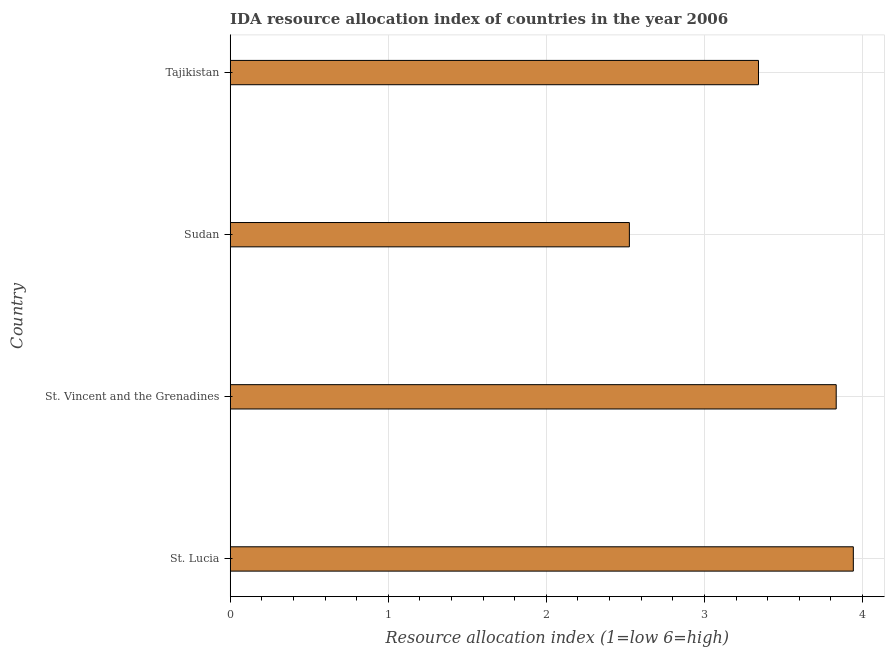Does the graph contain grids?
Offer a terse response. Yes. What is the title of the graph?
Your answer should be very brief. IDA resource allocation index of countries in the year 2006. What is the label or title of the X-axis?
Offer a very short reply. Resource allocation index (1=low 6=high). What is the ida resource allocation index in Tajikistan?
Make the answer very short. 3.34. Across all countries, what is the maximum ida resource allocation index?
Keep it short and to the point. 3.94. Across all countries, what is the minimum ida resource allocation index?
Offer a very short reply. 2.52. In which country was the ida resource allocation index maximum?
Make the answer very short. St. Lucia. In which country was the ida resource allocation index minimum?
Make the answer very short. Sudan. What is the sum of the ida resource allocation index?
Ensure brevity in your answer.  13.64. What is the difference between the ida resource allocation index in St. Lucia and Sudan?
Provide a succinct answer. 1.42. What is the average ida resource allocation index per country?
Keep it short and to the point. 3.41. What is the median ida resource allocation index?
Give a very brief answer. 3.59. In how many countries, is the ida resource allocation index greater than 2.6 ?
Your answer should be compact. 3. What is the ratio of the ida resource allocation index in St. Vincent and the Grenadines to that in Sudan?
Ensure brevity in your answer.  1.52. Is the difference between the ida resource allocation index in Sudan and Tajikistan greater than the difference between any two countries?
Your response must be concise. No. What is the difference between the highest and the second highest ida resource allocation index?
Offer a very short reply. 0.11. Is the sum of the ida resource allocation index in St. Lucia and Tajikistan greater than the maximum ida resource allocation index across all countries?
Your response must be concise. Yes. What is the difference between the highest and the lowest ida resource allocation index?
Offer a very short reply. 1.42. Are all the bars in the graph horizontal?
Offer a very short reply. Yes. How many countries are there in the graph?
Offer a terse response. 4. What is the Resource allocation index (1=low 6=high) in St. Lucia?
Give a very brief answer. 3.94. What is the Resource allocation index (1=low 6=high) in St. Vincent and the Grenadines?
Make the answer very short. 3.83. What is the Resource allocation index (1=low 6=high) in Sudan?
Keep it short and to the point. 2.52. What is the Resource allocation index (1=low 6=high) of Tajikistan?
Your response must be concise. 3.34. What is the difference between the Resource allocation index (1=low 6=high) in St. Lucia and St. Vincent and the Grenadines?
Provide a short and direct response. 0.11. What is the difference between the Resource allocation index (1=low 6=high) in St. Lucia and Sudan?
Give a very brief answer. 1.42. What is the difference between the Resource allocation index (1=low 6=high) in St. Lucia and Tajikistan?
Your answer should be very brief. 0.6. What is the difference between the Resource allocation index (1=low 6=high) in St. Vincent and the Grenadines and Sudan?
Provide a short and direct response. 1.31. What is the difference between the Resource allocation index (1=low 6=high) in St. Vincent and the Grenadines and Tajikistan?
Make the answer very short. 0.49. What is the difference between the Resource allocation index (1=low 6=high) in Sudan and Tajikistan?
Your answer should be compact. -0.82. What is the ratio of the Resource allocation index (1=low 6=high) in St. Lucia to that in St. Vincent and the Grenadines?
Ensure brevity in your answer.  1.03. What is the ratio of the Resource allocation index (1=low 6=high) in St. Lucia to that in Sudan?
Give a very brief answer. 1.56. What is the ratio of the Resource allocation index (1=low 6=high) in St. Lucia to that in Tajikistan?
Provide a succinct answer. 1.18. What is the ratio of the Resource allocation index (1=low 6=high) in St. Vincent and the Grenadines to that in Sudan?
Give a very brief answer. 1.52. What is the ratio of the Resource allocation index (1=low 6=high) in St. Vincent and the Grenadines to that in Tajikistan?
Make the answer very short. 1.15. What is the ratio of the Resource allocation index (1=low 6=high) in Sudan to that in Tajikistan?
Offer a very short reply. 0.76. 